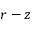<formula> <loc_0><loc_0><loc_500><loc_500>r - z</formula> 